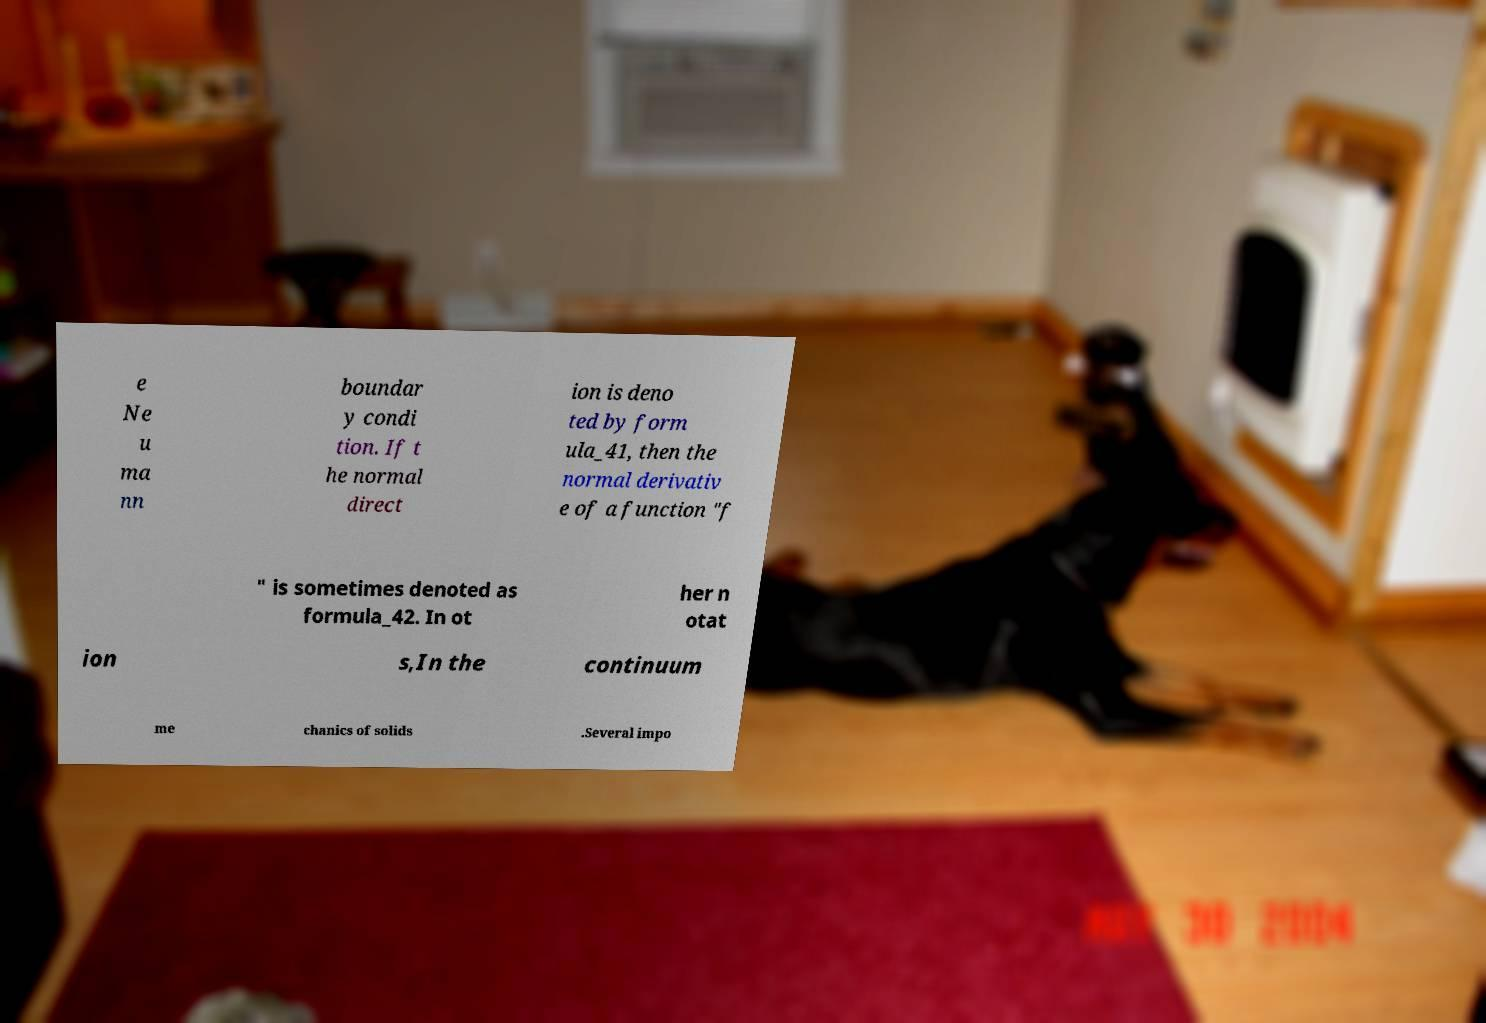Can you read and provide the text displayed in the image?This photo seems to have some interesting text. Can you extract and type it out for me? e Ne u ma nn boundar y condi tion. If t he normal direct ion is deno ted by form ula_41, then the normal derivativ e of a function "f " is sometimes denoted as formula_42. In ot her n otat ion s,In the continuum me chanics of solids .Several impo 